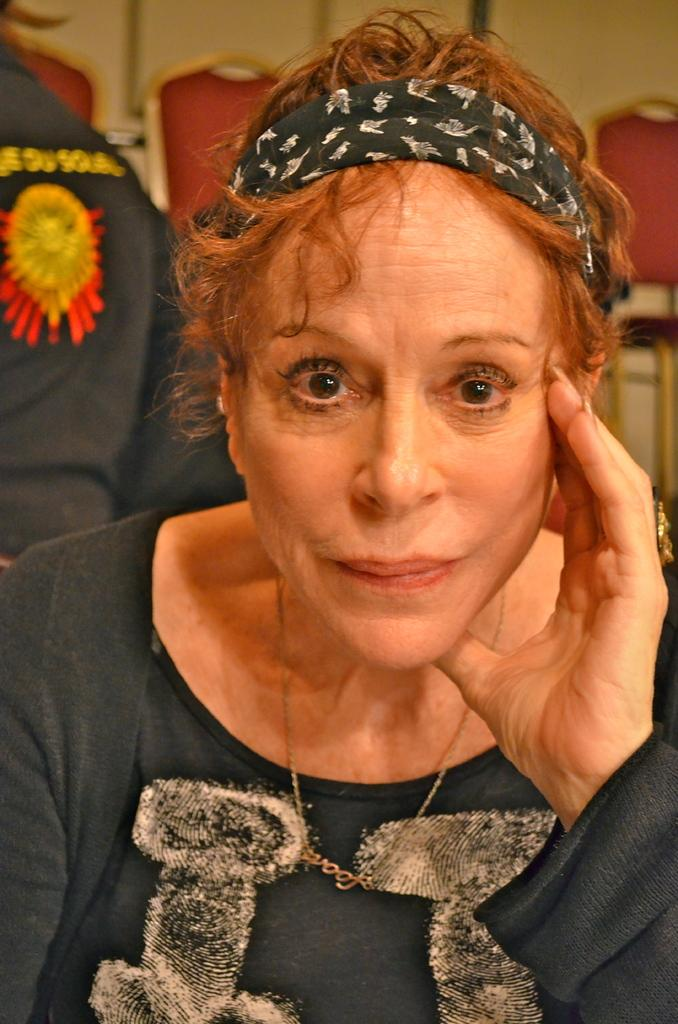What is the woman doing in the image? The woman is sitting in the image. Can you describe the setting in which the woman is sitting? There are chairs in the background of the image. What type of substance is the woman desiring in the image? There is no indication in the image that the woman is desiring any specific substance. 